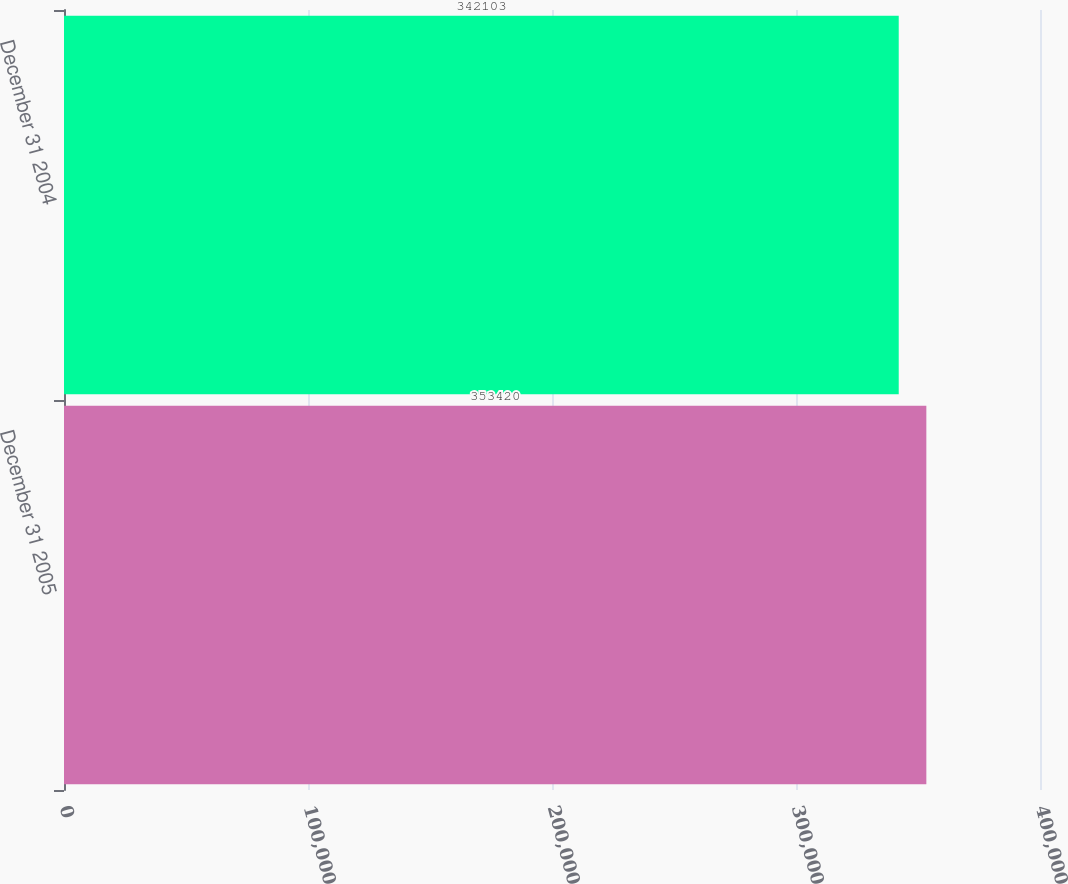Convert chart. <chart><loc_0><loc_0><loc_500><loc_500><bar_chart><fcel>December 31 2005<fcel>December 31 2004<nl><fcel>353420<fcel>342103<nl></chart> 